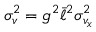Convert formula to latex. <formula><loc_0><loc_0><loc_500><loc_500>\sigma _ { v } ^ { 2 } = g ^ { 2 } \bar { \ell } ^ { 2 } \sigma _ { v _ { x } } ^ { 2 }</formula> 